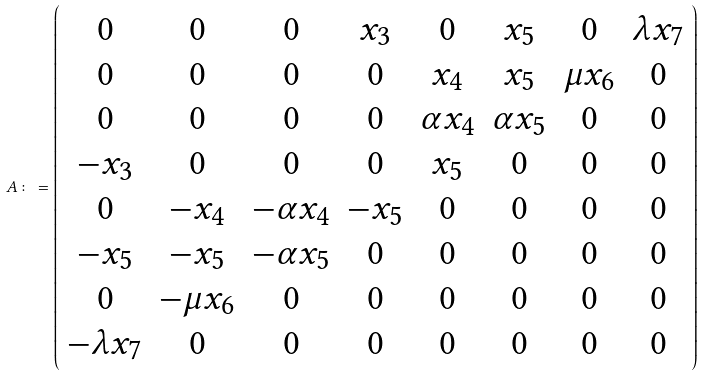<formula> <loc_0><loc_0><loc_500><loc_500>A \colon = \left ( \begin{array} { c c c c c c c c } 0 & 0 & 0 & x _ { 3 } & 0 & x _ { 5 } & 0 & \lambda x _ { 7 } \\ 0 & 0 & 0 & 0 & x _ { 4 } & x _ { 5 } & \mu x _ { 6 } & 0 \\ 0 & 0 & 0 & 0 & \alpha x _ { 4 } & \alpha x _ { 5 } & 0 & 0 \\ - x _ { 3 } & 0 & 0 & 0 & x _ { 5 } & 0 & 0 & 0 \\ 0 & - x _ { 4 } & - \alpha x _ { 4 } & - x _ { 5 } & 0 & 0 & 0 & 0 \\ - x _ { 5 } & - x _ { 5 } & - \alpha x _ { 5 } & 0 & 0 & 0 & 0 & 0 \\ 0 & - \mu x _ { 6 } & 0 & 0 & 0 & 0 & 0 & 0 \\ - \lambda x _ { 7 } & 0 & 0 & 0 & 0 & 0 & 0 & 0 \end{array} \right )</formula> 